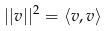<formula> <loc_0><loc_0><loc_500><loc_500>| | v | | ^ { 2 } = \langle v , v \rangle</formula> 